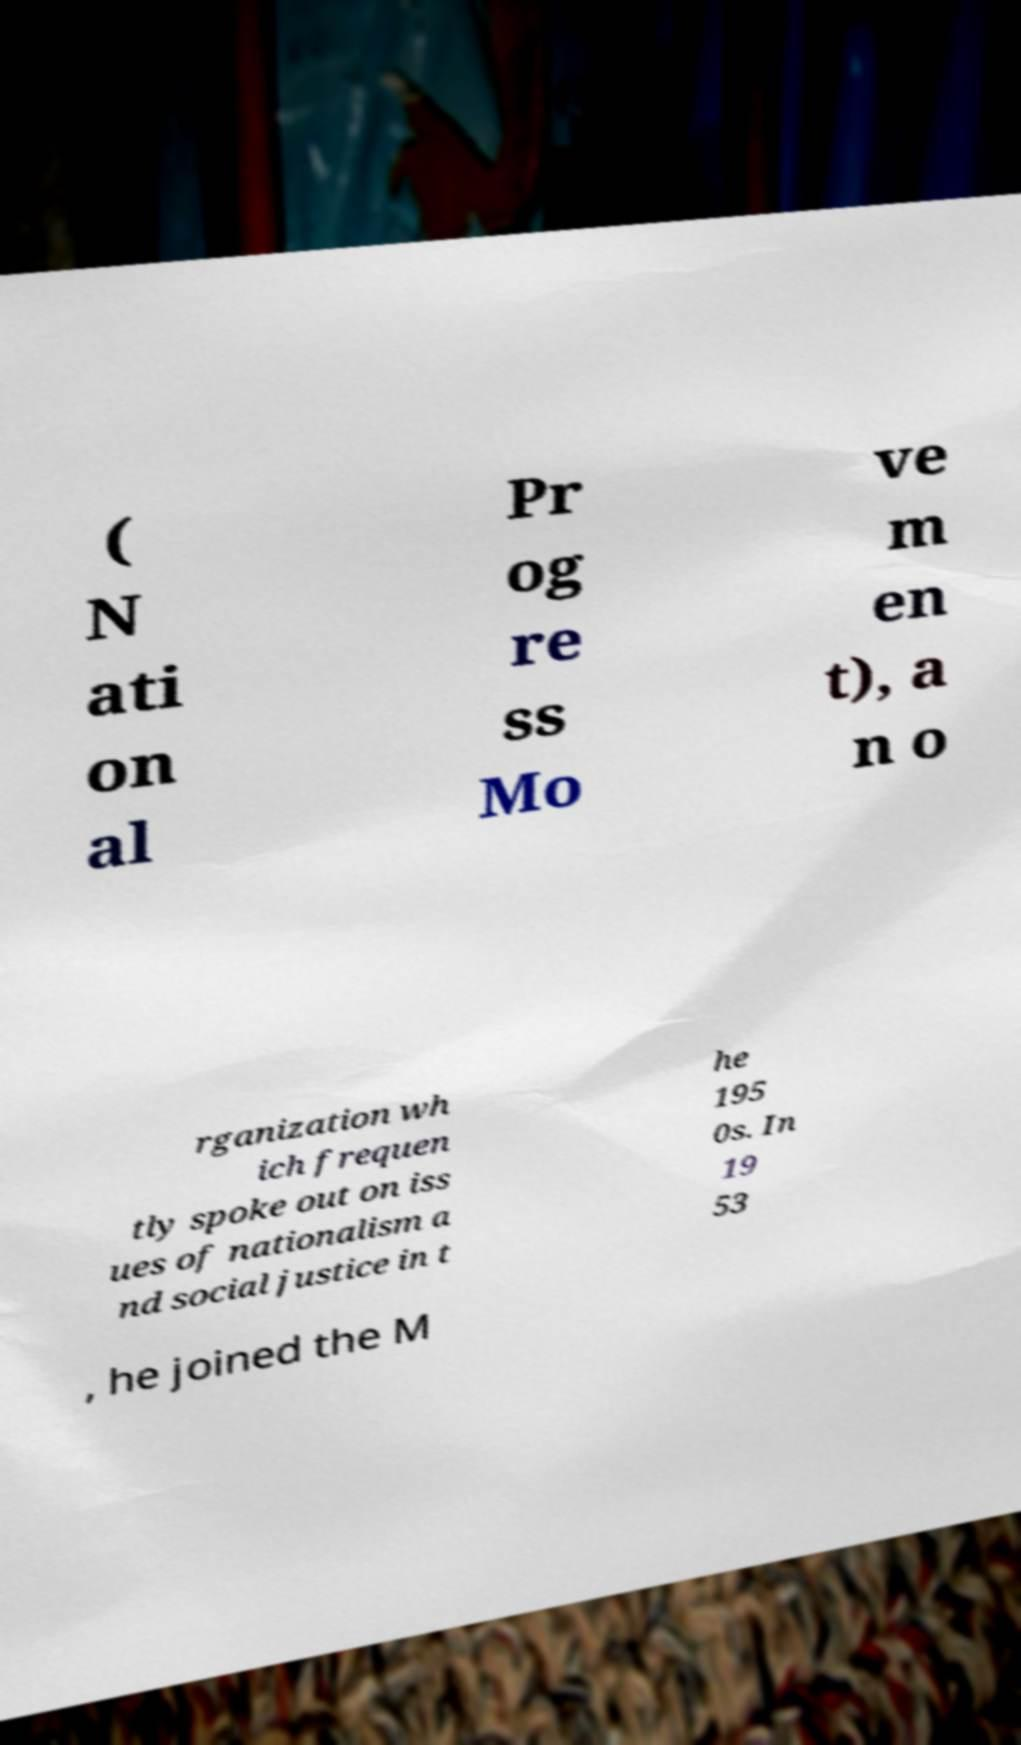Could you assist in decoding the text presented in this image and type it out clearly? ( N ati on al Pr og re ss Mo ve m en t), a n o rganization wh ich frequen tly spoke out on iss ues of nationalism a nd social justice in t he 195 0s. In 19 53 , he joined the M 